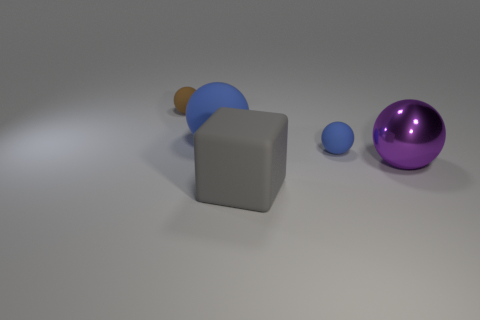Add 4 tiny blue spheres. How many objects exist? 9 Subtract all balls. How many objects are left? 1 Add 1 purple balls. How many purple balls are left? 2 Add 5 large purple things. How many large purple things exist? 6 Subtract 0 brown cylinders. How many objects are left? 5 Subtract all matte spheres. Subtract all tiny blue rubber spheres. How many objects are left? 1 